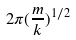Convert formula to latex. <formula><loc_0><loc_0><loc_500><loc_500>2 \pi ( \frac { m } { k } ) ^ { 1 / 2 }</formula> 